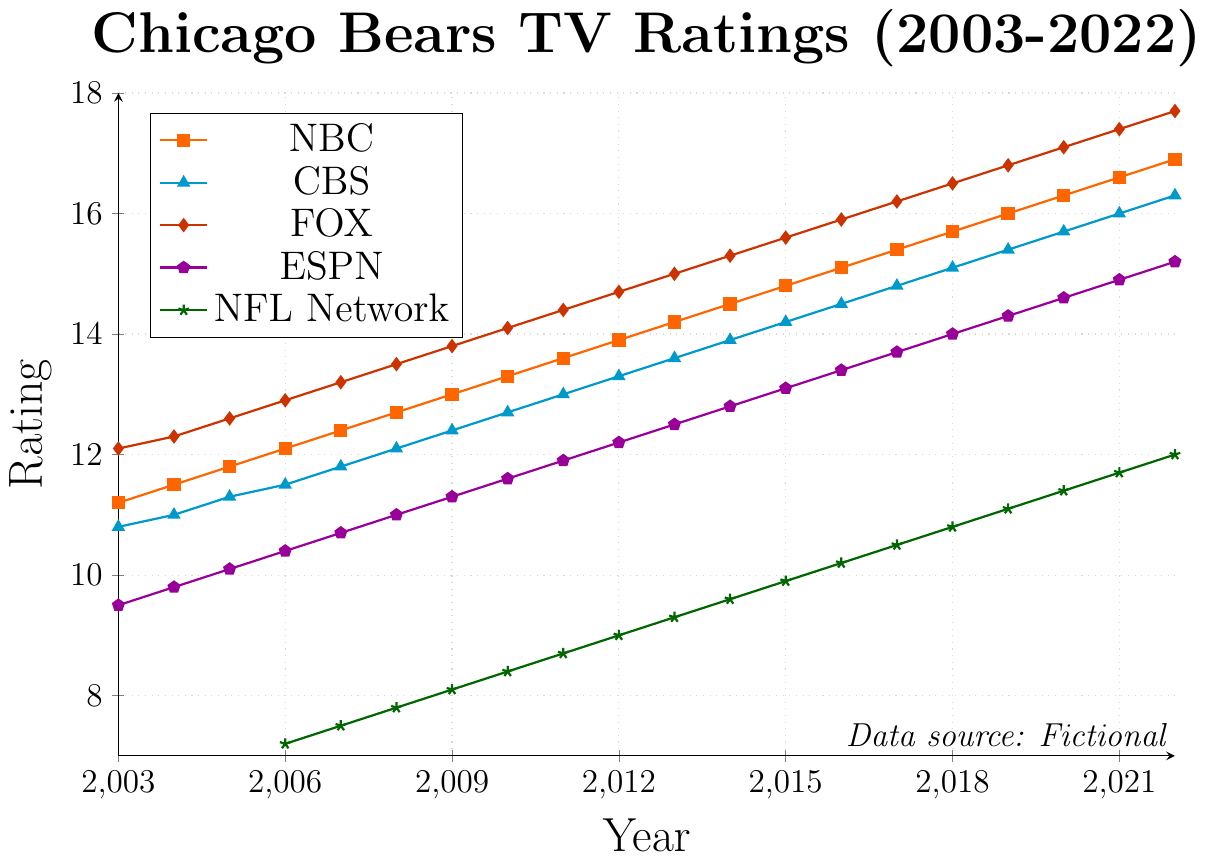Which broadcast network had the highest viewership ratings in 2022? The highest point for each network in 2022 is as follows: NBC = 16.9, CBS = 16.3, FOX = 17.7, ESPN = 15.2, NFL Network = 12.0. From these values, FOX had the highest rating.
Answer: FOX How did the viewership rating for ESPN change from 2006 to 2022? The rating for ESPN in 2006 was 10.4 and in 2022 it was 15.2. The change can be found by subtracting 10.4 from 15.2, which is 15.2 - 10.4 = 4.8.
Answer: Increased by 4.8 Between which two successive years did CBS see its largest increase in viewership ratings? To find the largest increase, the differences between successive years need to be calculated: 
- (2004 - 2003) = 11.0 - 10.8 = 0.2
- (2005 - 2004) = 11.3 - 11.0 = 0.3
- (2006 - 2005) = 11.5 - 11.3 = 0.2
- and so on.
The largest increase occurs between 2021 and 2022, which is 16.3 - 16.0 = 0.3.
Answer: 2021 and 2022 What is the average TV viewership rating for NBC over the entire time span displayed? Sum of NBC ratings from 2003 to 2022: 11.2 + 11.5 + 11.8 + 12.1 + 12.4 + 12.7 + 13.0 + 13.3 + 13.6 + 13.9 + 14.2 + 14.5 + 14.8 + 15.1 + 15.4 + 15.7 + 16.0 + 16.3 + 16.6 + 16.9 = 279.4. Dividing this sum by the number of years (20) gives the average rating: 279.4 / 20 = 13.97.
Answer: 13.97 Which network consistently had the lowest viewership ratings from 2006 onwards? From examining the data for 2006 to 2022, the NFL Network consistently has the lowest ratings each year. For example:
- 2006: 7.2
- 2007: 7.5
- and so on, always lower than other networks in corresponding years.
Answer: NFL Network Did any network exceed a viewership rating of 17 before 2020? From the data, only in 2020 did FOX exceed a rating of 17 with a 17.1. Prior to 2020, no network exceeded a rating of 17.
Answer: No During which year did NBC, CBS, FOX, and ESPN all have increased viewership ratings compared to the previous year? Checking the ratings for consecutive years:
- Comparing 2017 to 2016 for NBC = 15.4 > 15.1, for CBS = 14.8 > 14.5, for FOX = 16.2 > 15.9, for ESPN = 13.7 > 13.4.
So, in 2017, all four networks had increased ratings compared to 2016.
Answer: 2017 Which network had the smallest increase in viewership from 2003 to 2022? Comparing the initial and final ratings:
- NBC: 16.9 - 11.2 = 5.7
- CBS: 16.3 - 10.8 = 5.5
- FOX: 17.7 - 12.1 = 5.6
- ESPN: 15.2 - 9.5 = 5.7
- NFL: 12.0 - 7.2 = 4.8
CBS had the smallest increase at 5.5.
Answer: CBS Which network had the highest variance in viewership ratings over the given period? The variance can be calculated by taking the mean of squared deviations from the average rating for each network. Visually inspecting the chart, FOX has the largest swings on the y-axis across the years.
Answer: FOX 